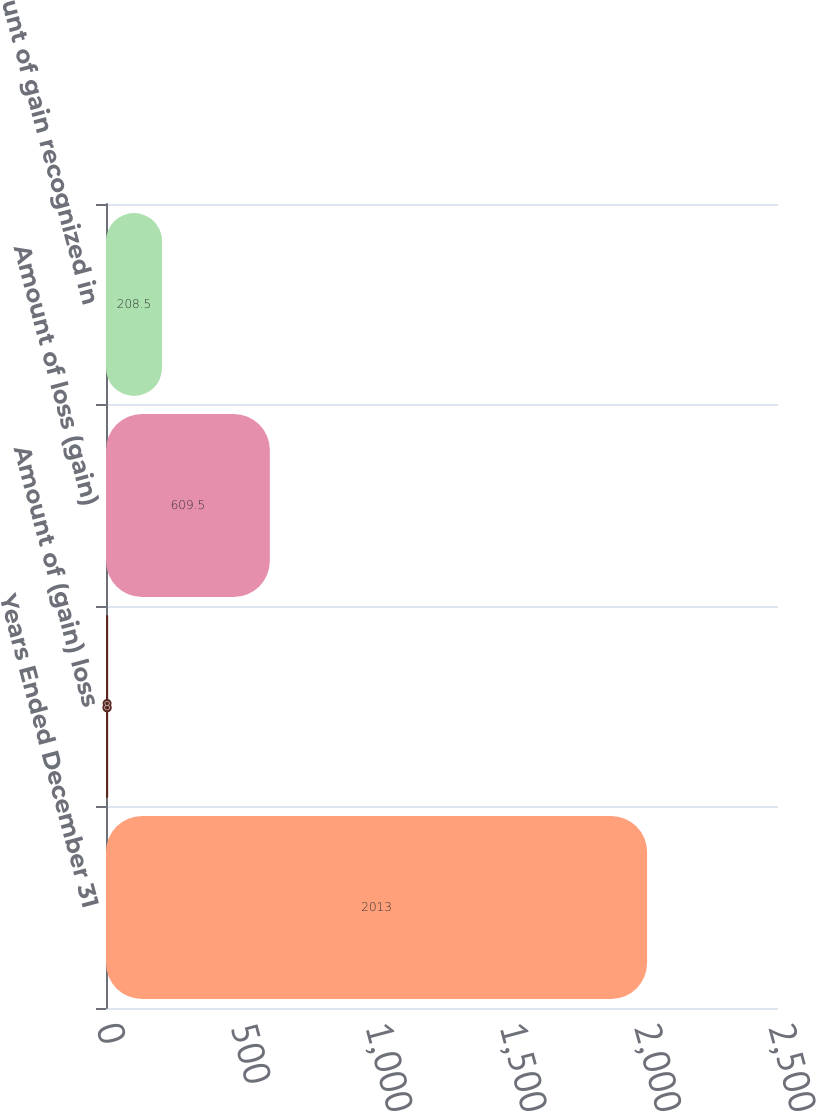Convert chart. <chart><loc_0><loc_0><loc_500><loc_500><bar_chart><fcel>Years Ended December 31<fcel>Amount of (gain) loss<fcel>Amount of loss (gain)<fcel>Amount of gain recognized in<nl><fcel>2013<fcel>8<fcel>609.5<fcel>208.5<nl></chart> 